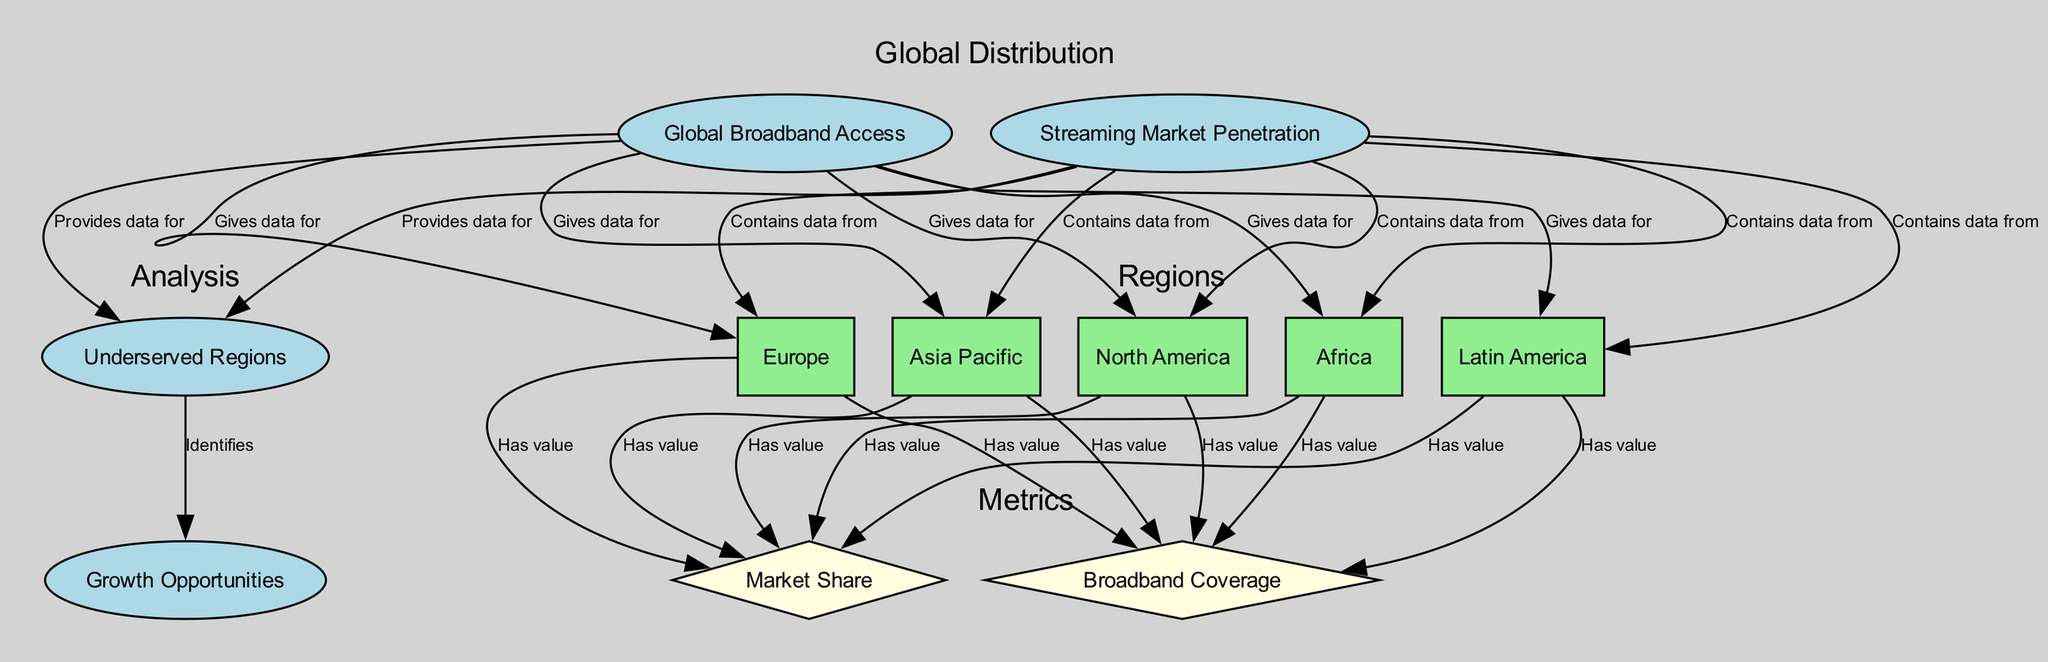What are the regions represented in the diagram? The diagram includes five regions: North America, Europe, Asia Pacific, Latin America, and Africa. These regions are explicitly labeled as categories connected to both Global Broadband Access and Streaming Market Penetration.
Answer: North America, Europe, Asia Pacific, Latin America, Africa Which region has the highest broadband coverage? To find this, we would look at the connections coming from each regional node to the Broadband Coverage metric. The data for each region reflects its respective coverage. The specific region with the highest coverage would be immediately visible in the diagram.
Answer: [The specific region indicated in the diagram] What does the edge labeled "Identifies" signify? This edge connects Underserved Regions to Growth Opportunities. It signifies that identifying the underserved regions provides insights into potential areas for market expansion in streaming services.
Answer: Identifies growth opportunities How many edges are connected to the North America node? By counting the number of edges connected to the North America node in the diagram, we observe all connections to both broadband coverage and market share metrics as well as data connections to the broader themes of global broadband access and streaming market penetration.
Answer: 5 What type of data does the Streaming Market Penetration node provide? The Streaming Market Penetration node provides data for each of the regions studied, connecting specifically to their respective market share values, representing the penetration of streaming services in those areas.
Answer: Market share values Which regions are defined as underserved? The Underserved Regions node aggregates data from both Global Broadband Access and Streaming Market Penetration. The underserved regions are identified based on their low access to both broadband and streaming services, which may vary based on the displayed information.
Answer: [The specific regions indicated in the diagram] What is the relationship between Underserved Regions and Growth Opportunities? The relationship is direct; Underserved Regions identifies potential places where streaming services can expand, indicating that these identified areas represent opportunities for growth in the market.
Answer: Growth opportunities How is Asia Pacific's market share related in the diagram? Asia Pacific is linked to the Streaming Market Penetration node, showing its market share connected with other regions, indicating the extent of streaming services' reach in that particular area.
Answer: [The specific market share value indicated in the diagram] 